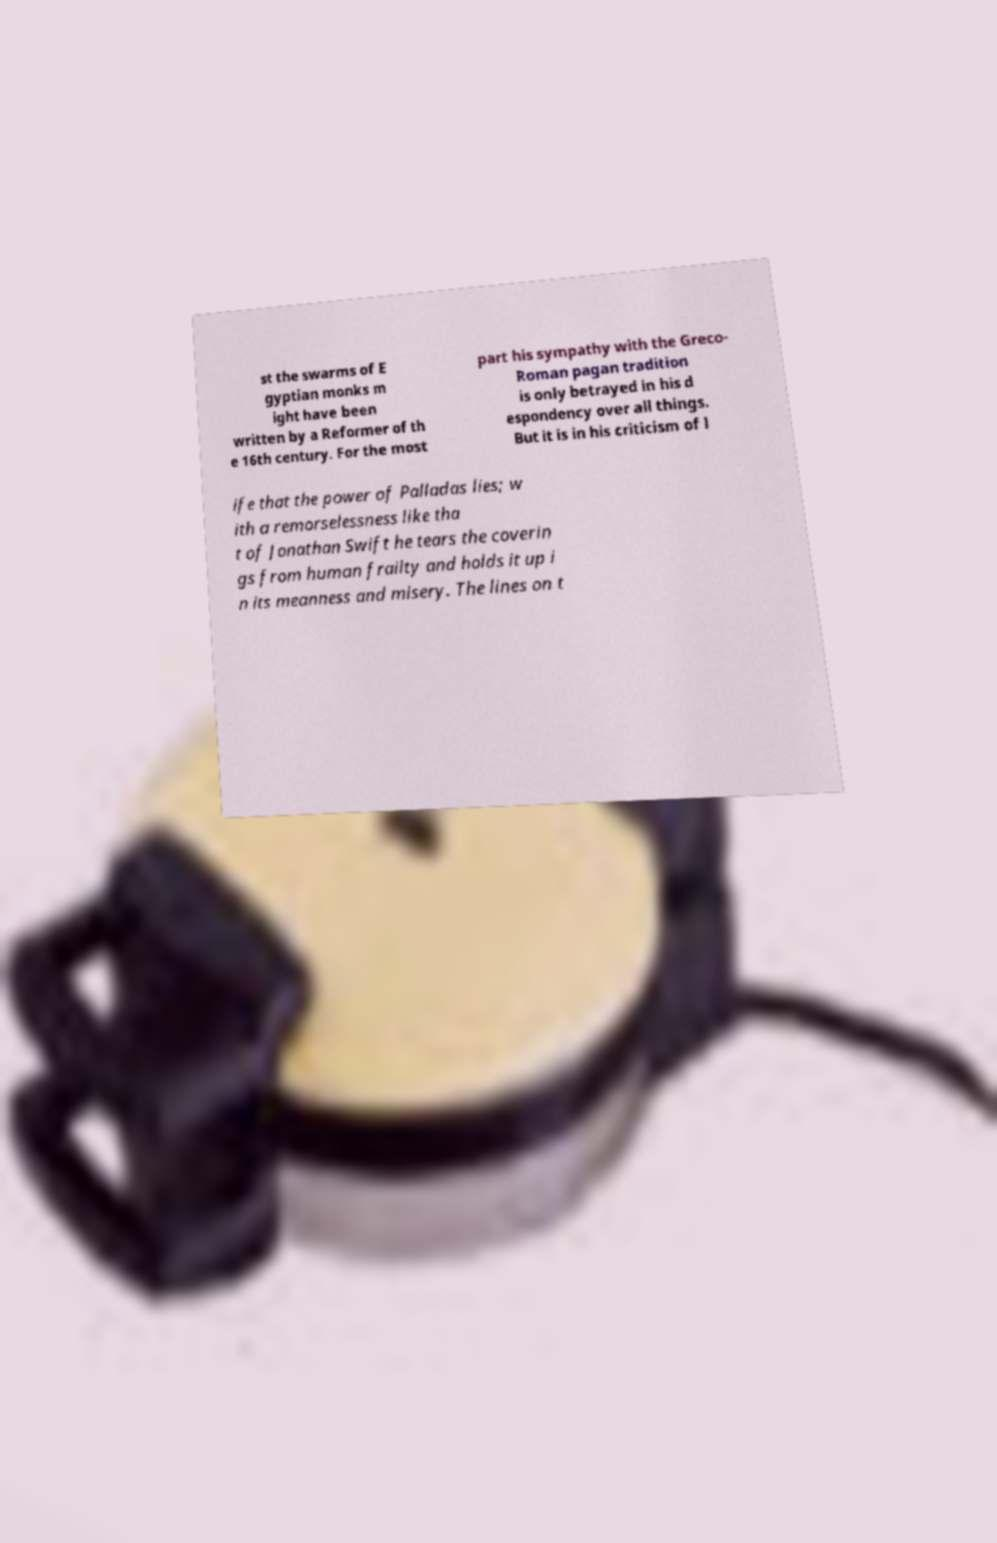I need the written content from this picture converted into text. Can you do that? st the swarms of E gyptian monks m ight have been written by a Reformer of th e 16th century. For the most part his sympathy with the Greco- Roman pagan tradition is only betrayed in his d espondency over all things. But it is in his criticism of l ife that the power of Palladas lies; w ith a remorselessness like tha t of Jonathan Swift he tears the coverin gs from human frailty and holds it up i n its meanness and misery. The lines on t 